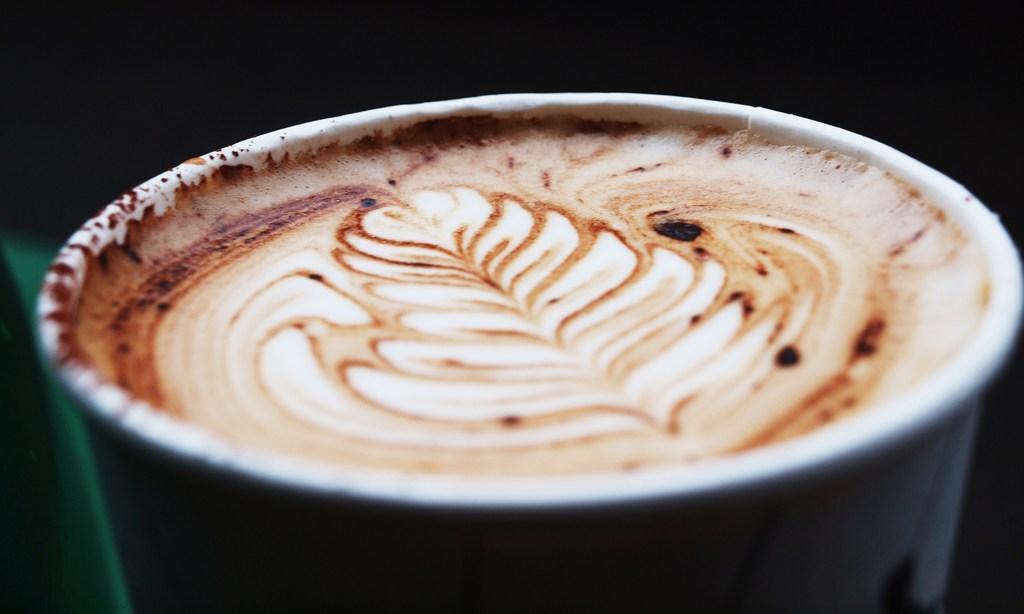Please provide a concise description of this image. In this picture we can see cup with coffee. In the background of the image it is dark. 